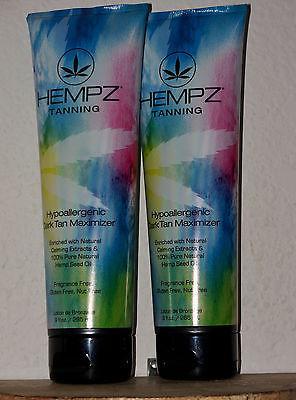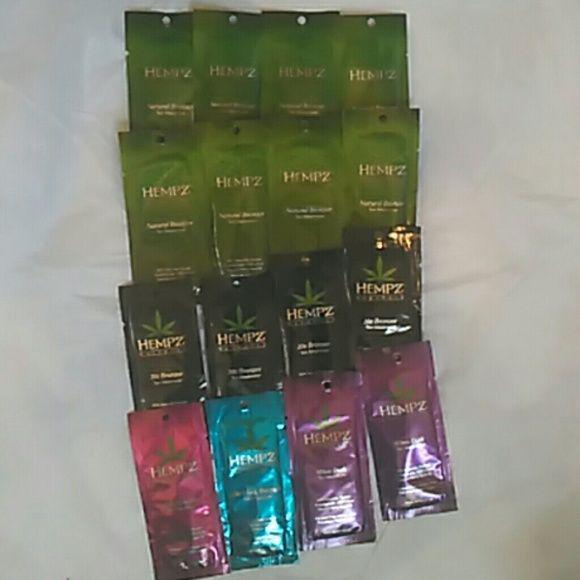The first image is the image on the left, the second image is the image on the right. Evaluate the accuracy of this statement regarding the images: "An image shows only pump-top products.". Is it true? Answer yes or no. No. The first image is the image on the left, the second image is the image on the right. Examine the images to the left and right. Is the description "Two bottles of lotion stand together in the image on the left." accurate? Answer yes or no. Yes. 